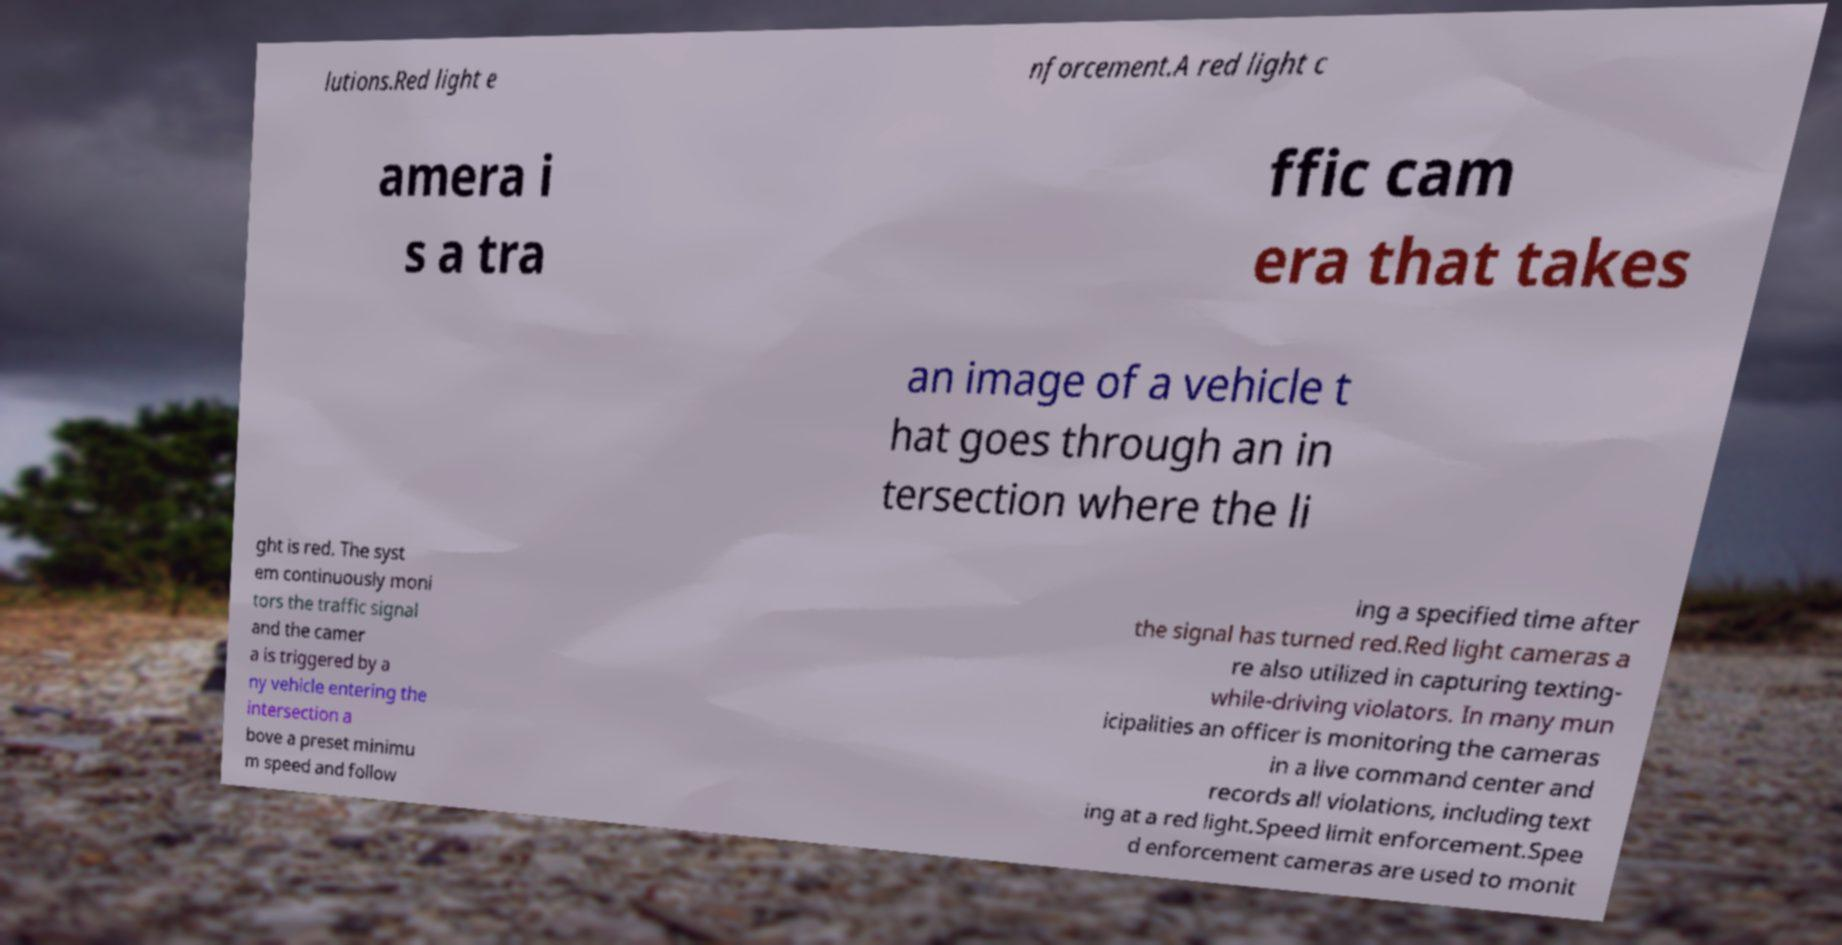Please read and relay the text visible in this image. What does it say? lutions.Red light e nforcement.A red light c amera i s a tra ffic cam era that takes an image of a vehicle t hat goes through an in tersection where the li ght is red. The syst em continuously moni tors the traffic signal and the camer a is triggered by a ny vehicle entering the intersection a bove a preset minimu m speed and follow ing a specified time after the signal has turned red.Red light cameras a re also utilized in capturing texting- while-driving violators. In many mun icipalities an officer is monitoring the cameras in a live command center and records all violations, including text ing at a red light.Speed limit enforcement.Spee d enforcement cameras are used to monit 